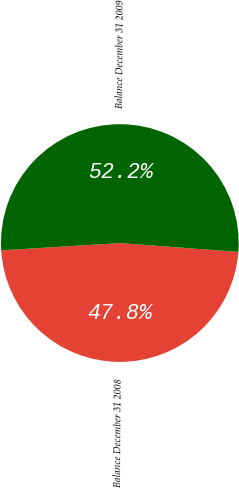Convert chart to OTSL. <chart><loc_0><loc_0><loc_500><loc_500><pie_chart><fcel>Balance December 31 2008<fcel>Balance December 31 2009<nl><fcel>47.83%<fcel>52.17%<nl></chart> 